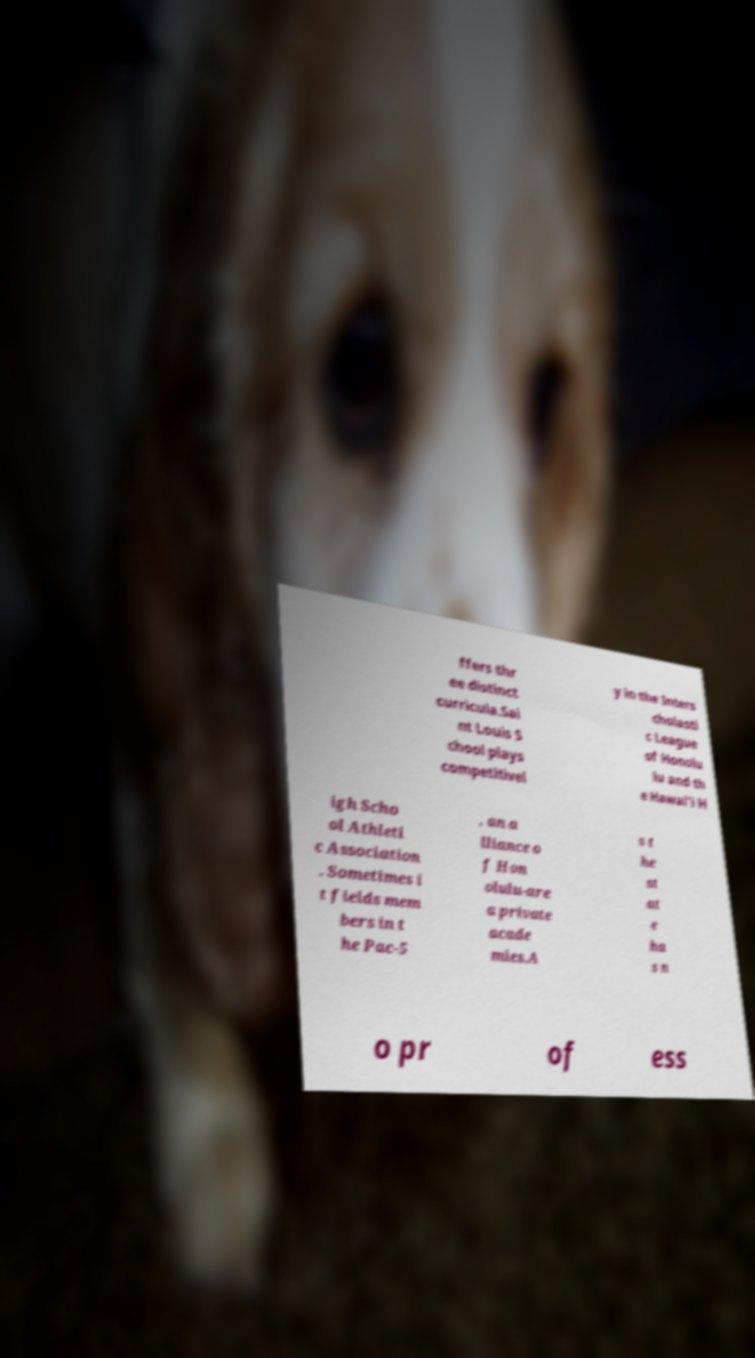Please identify and transcribe the text found in this image. ffers thr ee distinct curricula.Sai nt Louis S chool plays competitivel y in the Inters cholasti c League of Honolu lu and th e Hawai'i H igh Scho ol Athleti c Association . Sometimes i t fields mem bers in t he Pac-5 , an a lliance o f Hon olulu-are a private acade mies.A s t he st at e ha s n o pr of ess 